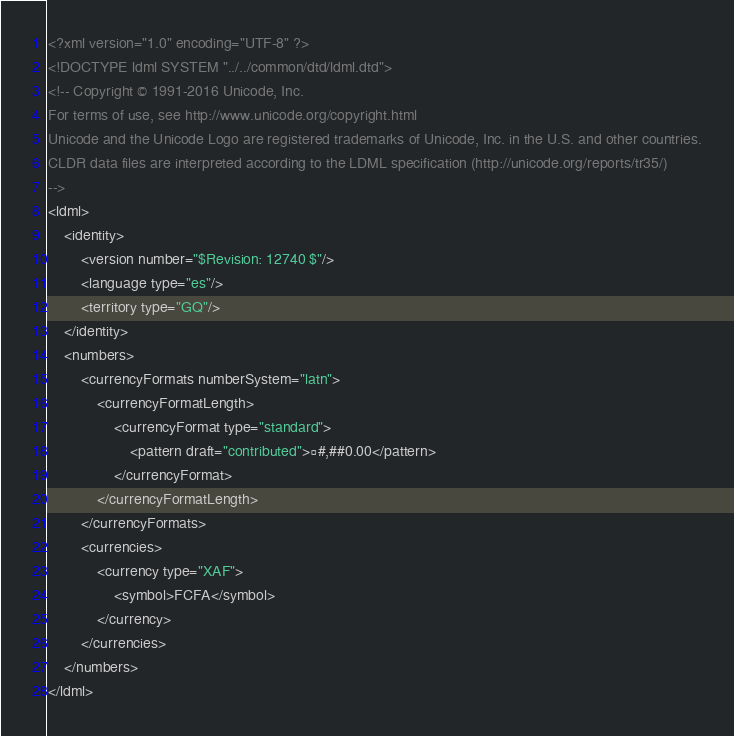Convert code to text. <code><loc_0><loc_0><loc_500><loc_500><_XML_><?xml version="1.0" encoding="UTF-8" ?>
<!DOCTYPE ldml SYSTEM "../../common/dtd/ldml.dtd">
<!-- Copyright © 1991-2016 Unicode, Inc.
For terms of use, see http://www.unicode.org/copyright.html
Unicode and the Unicode Logo are registered trademarks of Unicode, Inc. in the U.S. and other countries.
CLDR data files are interpreted according to the LDML specification (http://unicode.org/reports/tr35/)
-->
<ldml>
	<identity>
		<version number="$Revision: 12740 $"/>
		<language type="es"/>
		<territory type="GQ"/>
	</identity>
	<numbers>
		<currencyFormats numberSystem="latn">
			<currencyFormatLength>
				<currencyFormat type="standard">
					<pattern draft="contributed">¤#,##0.00</pattern>
				</currencyFormat>
			</currencyFormatLength>
		</currencyFormats>
		<currencies>
			<currency type="XAF">
				<symbol>FCFA</symbol>
			</currency>
		</currencies>
	</numbers>
</ldml>
</code> 